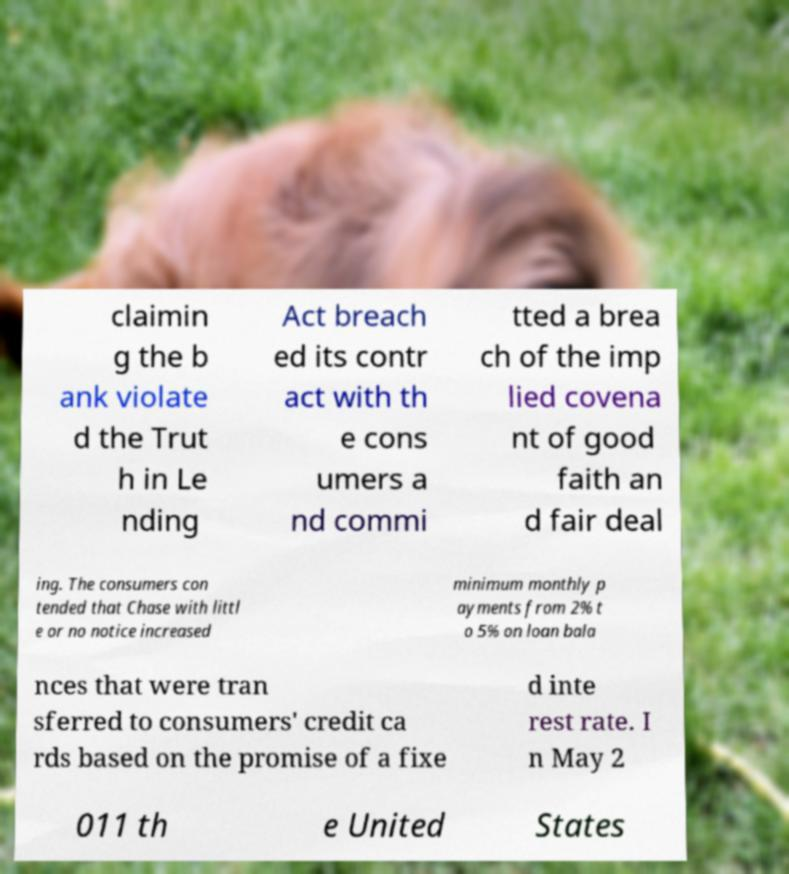What messages or text are displayed in this image? I need them in a readable, typed format. claimin g the b ank violate d the Trut h in Le nding Act breach ed its contr act with th e cons umers a nd commi tted a brea ch of the imp lied covena nt of good faith an d fair deal ing. The consumers con tended that Chase with littl e or no notice increased minimum monthly p ayments from 2% t o 5% on loan bala nces that were tran sferred to consumers' credit ca rds based on the promise of a fixe d inte rest rate. I n May 2 011 th e United States 